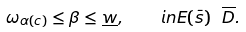<formula> <loc_0><loc_0><loc_500><loc_500>\omega _ { \alpha ( c ) } \leq \beta \leq \underline { w } , \quad i n E ( \bar { s } ) \ { \overline { D } } .</formula> 